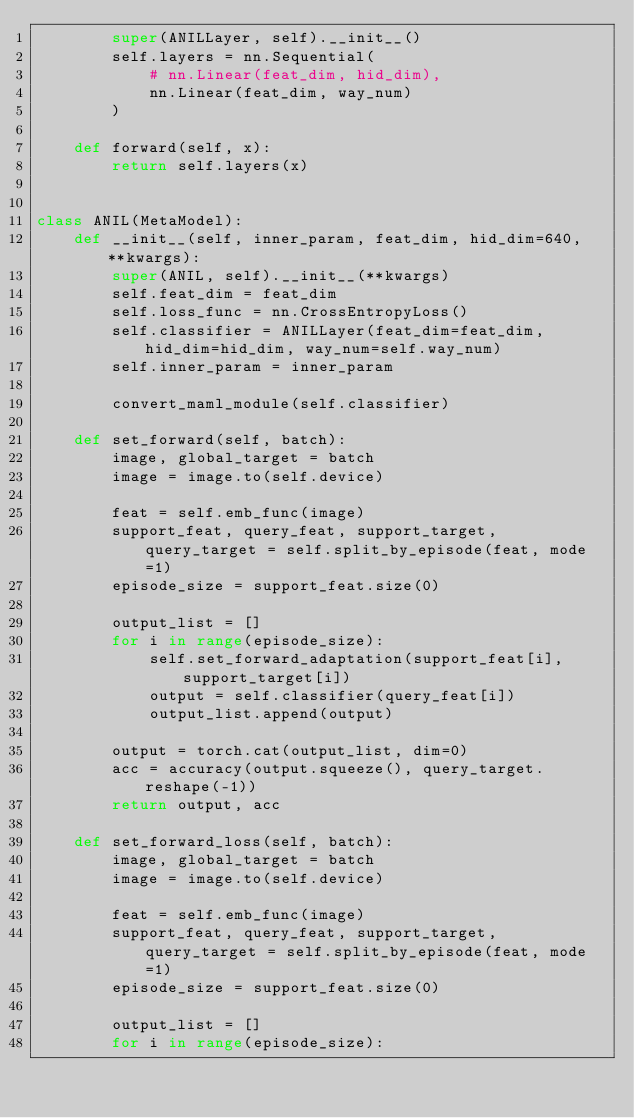<code> <loc_0><loc_0><loc_500><loc_500><_Python_>        super(ANILLayer, self).__init__()
        self.layers = nn.Sequential(
            # nn.Linear(feat_dim, hid_dim),
            nn.Linear(feat_dim, way_num)
        )

    def forward(self, x):
        return self.layers(x)


class ANIL(MetaModel):
    def __init__(self, inner_param, feat_dim, hid_dim=640, **kwargs):
        super(ANIL, self).__init__(**kwargs)
        self.feat_dim = feat_dim
        self.loss_func = nn.CrossEntropyLoss()
        self.classifier = ANILLayer(feat_dim=feat_dim, hid_dim=hid_dim, way_num=self.way_num)
        self.inner_param = inner_param

        convert_maml_module(self.classifier)

    def set_forward(self, batch):
        image, global_target = batch
        image = image.to(self.device)

        feat = self.emb_func(image)
        support_feat, query_feat, support_target, query_target = self.split_by_episode(feat, mode=1)
        episode_size = support_feat.size(0)

        output_list = []
        for i in range(episode_size):
            self.set_forward_adaptation(support_feat[i], support_target[i])
            output = self.classifier(query_feat[i])
            output_list.append(output)

        output = torch.cat(output_list, dim=0)
        acc = accuracy(output.squeeze(), query_target.reshape(-1))
        return output, acc

    def set_forward_loss(self, batch):
        image, global_target = batch
        image = image.to(self.device)

        feat = self.emb_func(image)
        support_feat, query_feat, support_target, query_target = self.split_by_episode(feat, mode=1)
        episode_size = support_feat.size(0)

        output_list = []
        for i in range(episode_size):</code> 